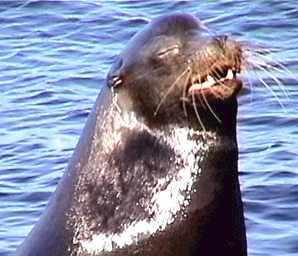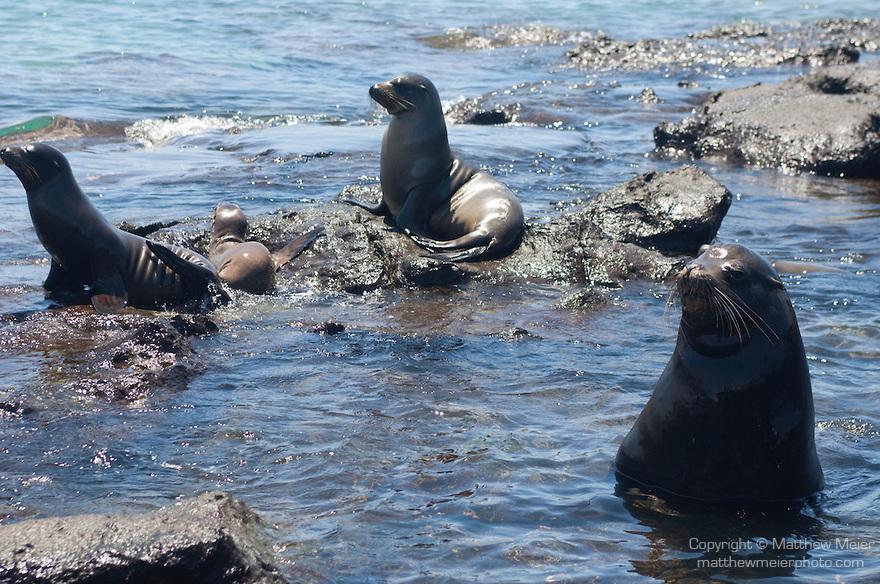The first image is the image on the left, the second image is the image on the right. Considering the images on both sides, is "Each image includes a dark, wet seal with its head upright, and in at least one image, rocks jut out of the water." valid? Answer yes or no. Yes. The first image is the image on the left, the second image is the image on the right. Analyze the images presented: Is the assertion "The left image contains no more than one seal." valid? Answer yes or no. Yes. 